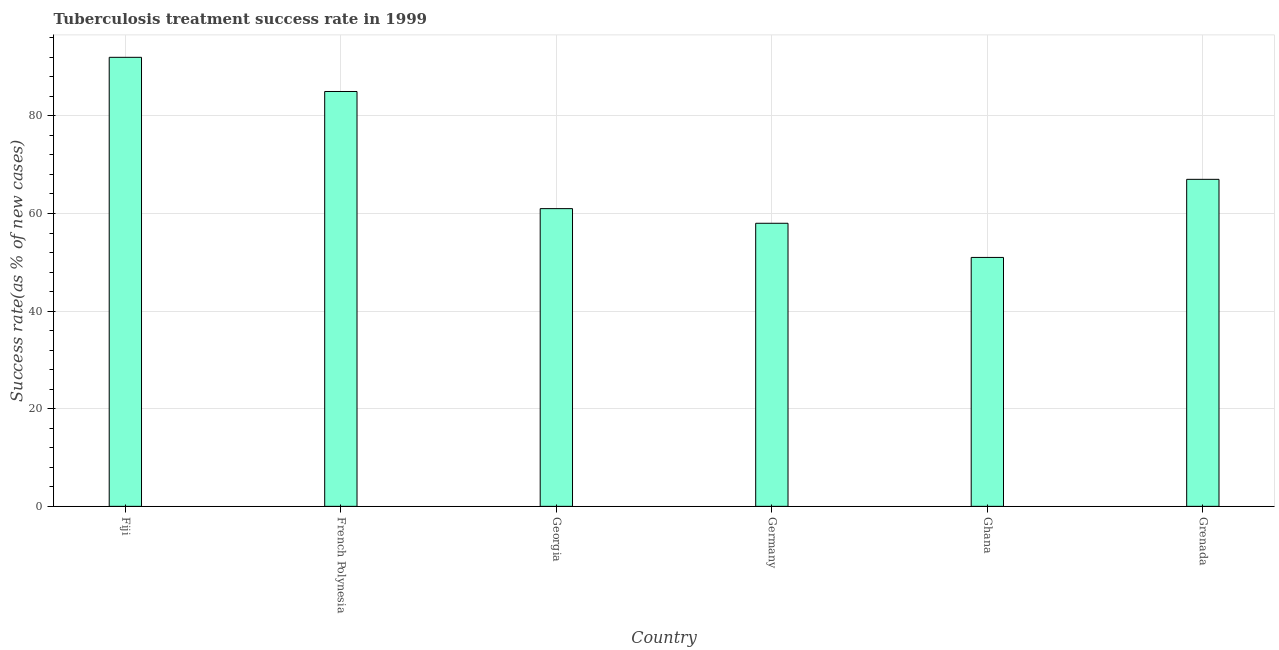What is the title of the graph?
Make the answer very short. Tuberculosis treatment success rate in 1999. What is the label or title of the Y-axis?
Provide a succinct answer. Success rate(as % of new cases). What is the tuberculosis treatment success rate in Fiji?
Provide a short and direct response. 92. Across all countries, what is the maximum tuberculosis treatment success rate?
Provide a succinct answer. 92. In which country was the tuberculosis treatment success rate maximum?
Give a very brief answer. Fiji. What is the sum of the tuberculosis treatment success rate?
Provide a short and direct response. 414. What is the difference between the tuberculosis treatment success rate in Germany and Ghana?
Offer a very short reply. 7. What is the average tuberculosis treatment success rate per country?
Ensure brevity in your answer.  69. What is the ratio of the tuberculosis treatment success rate in French Polynesia to that in Germany?
Provide a short and direct response. 1.47. Is the difference between the tuberculosis treatment success rate in Fiji and Germany greater than the difference between any two countries?
Your answer should be compact. No. Is the sum of the tuberculosis treatment success rate in Georgia and Germany greater than the maximum tuberculosis treatment success rate across all countries?
Ensure brevity in your answer.  Yes. In how many countries, is the tuberculosis treatment success rate greater than the average tuberculosis treatment success rate taken over all countries?
Ensure brevity in your answer.  2. Are all the bars in the graph horizontal?
Keep it short and to the point. No. How many countries are there in the graph?
Make the answer very short. 6. What is the difference between two consecutive major ticks on the Y-axis?
Your answer should be compact. 20. What is the Success rate(as % of new cases) of Fiji?
Provide a short and direct response. 92. What is the Success rate(as % of new cases) in Georgia?
Give a very brief answer. 61. What is the difference between the Success rate(as % of new cases) in Fiji and Georgia?
Keep it short and to the point. 31. What is the difference between the Success rate(as % of new cases) in Fiji and Grenada?
Give a very brief answer. 25. What is the difference between the Success rate(as % of new cases) in French Polynesia and Germany?
Your answer should be compact. 27. What is the difference between the Success rate(as % of new cases) in French Polynesia and Grenada?
Offer a very short reply. 18. What is the difference between the Success rate(as % of new cases) in Georgia and Grenada?
Give a very brief answer. -6. What is the difference between the Success rate(as % of new cases) in Germany and Ghana?
Give a very brief answer. 7. What is the ratio of the Success rate(as % of new cases) in Fiji to that in French Polynesia?
Make the answer very short. 1.08. What is the ratio of the Success rate(as % of new cases) in Fiji to that in Georgia?
Your response must be concise. 1.51. What is the ratio of the Success rate(as % of new cases) in Fiji to that in Germany?
Your answer should be compact. 1.59. What is the ratio of the Success rate(as % of new cases) in Fiji to that in Ghana?
Make the answer very short. 1.8. What is the ratio of the Success rate(as % of new cases) in Fiji to that in Grenada?
Provide a short and direct response. 1.37. What is the ratio of the Success rate(as % of new cases) in French Polynesia to that in Georgia?
Ensure brevity in your answer.  1.39. What is the ratio of the Success rate(as % of new cases) in French Polynesia to that in Germany?
Make the answer very short. 1.47. What is the ratio of the Success rate(as % of new cases) in French Polynesia to that in Ghana?
Provide a short and direct response. 1.67. What is the ratio of the Success rate(as % of new cases) in French Polynesia to that in Grenada?
Your response must be concise. 1.27. What is the ratio of the Success rate(as % of new cases) in Georgia to that in Germany?
Your response must be concise. 1.05. What is the ratio of the Success rate(as % of new cases) in Georgia to that in Ghana?
Provide a succinct answer. 1.2. What is the ratio of the Success rate(as % of new cases) in Georgia to that in Grenada?
Keep it short and to the point. 0.91. What is the ratio of the Success rate(as % of new cases) in Germany to that in Ghana?
Your answer should be compact. 1.14. What is the ratio of the Success rate(as % of new cases) in Germany to that in Grenada?
Offer a terse response. 0.87. What is the ratio of the Success rate(as % of new cases) in Ghana to that in Grenada?
Provide a succinct answer. 0.76. 